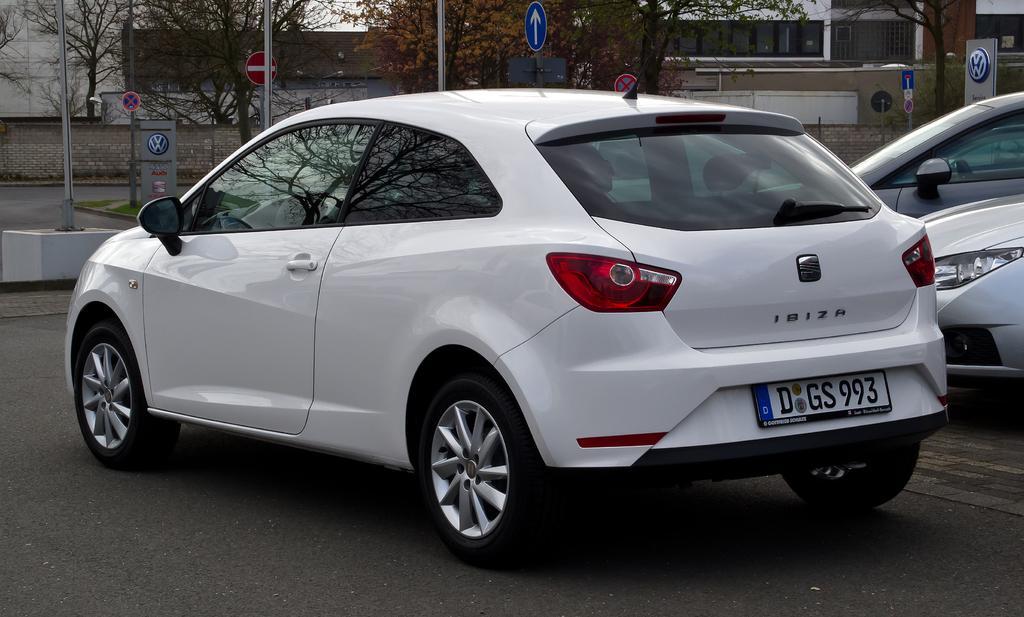Please provide a concise description of this image. This image consists of cars. In the front, there is a car in white color. At the bottom, there is a road. In the background, there are trees and wall. On the right, it looks like a building. 